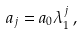Convert formula to latex. <formula><loc_0><loc_0><loc_500><loc_500>a _ { j } = a _ { 0 } \lambda _ { 1 } ^ { j } \, ,</formula> 